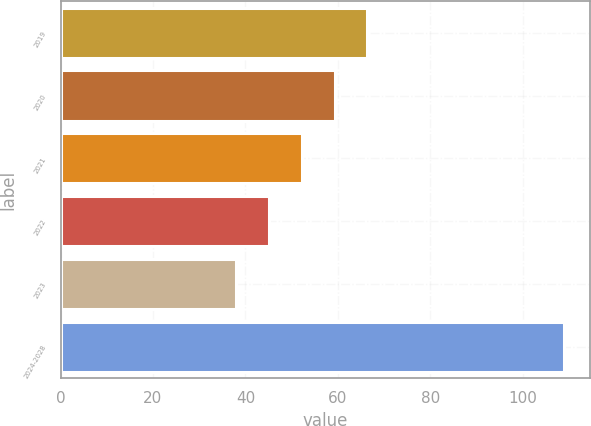Convert chart to OTSL. <chart><loc_0><loc_0><loc_500><loc_500><bar_chart><fcel>2019<fcel>2020<fcel>2021<fcel>2022<fcel>2023<fcel>2024-2028<nl><fcel>66.4<fcel>59.3<fcel>52.2<fcel>45.1<fcel>38<fcel>109<nl></chart> 